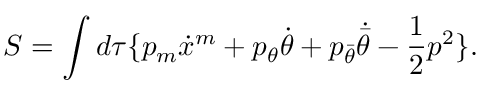<formula> <loc_0><loc_0><loc_500><loc_500>S = \int d \tau \{ p _ { m } \dot { x } ^ { m } + p _ { \theta } \dot { \theta } + p _ { \bar { \theta } } \dot { \bar { \theta } } - \frac { 1 } { 2 } p ^ { 2 } \} .</formula> 